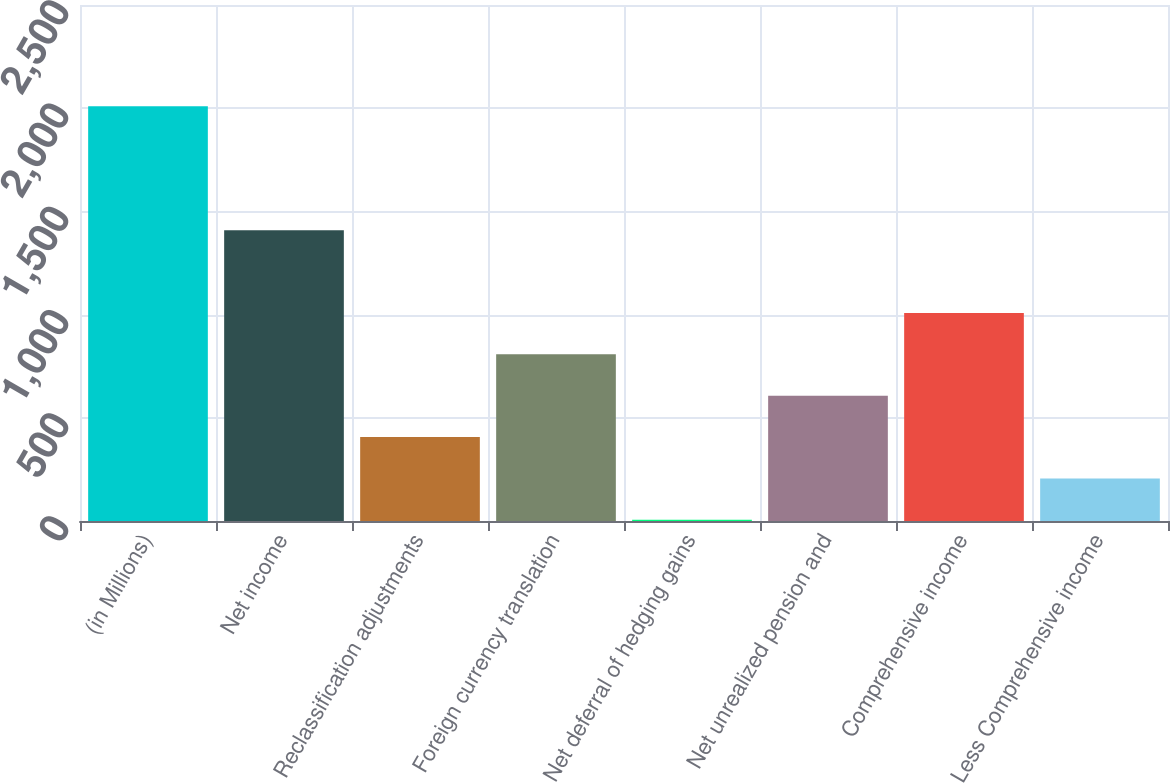<chart> <loc_0><loc_0><loc_500><loc_500><bar_chart><fcel>(in Millions)<fcel>Net income<fcel>Reclassification adjustments<fcel>Foreign currency translation<fcel>Net deferral of hedging gains<fcel>Net unrealized pension and<fcel>Comprehensive income<fcel>Less Comprehensive income<nl><fcel>2010<fcel>1408.77<fcel>406.72<fcel>807.54<fcel>5.9<fcel>607.13<fcel>1007.95<fcel>206.31<nl></chart> 